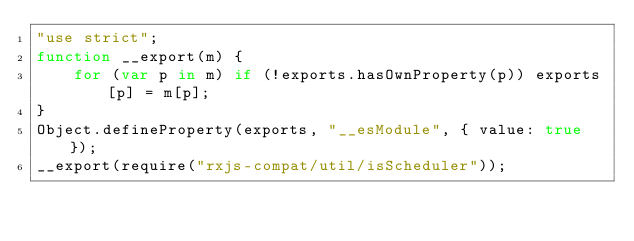<code> <loc_0><loc_0><loc_500><loc_500><_JavaScript_>"use strict";
function __export(m) {
    for (var p in m) if (!exports.hasOwnProperty(p)) exports[p] = m[p];
}
Object.defineProperty(exports, "__esModule", { value: true });
__export(require("rxjs-compat/util/isScheduler"));
</code> 